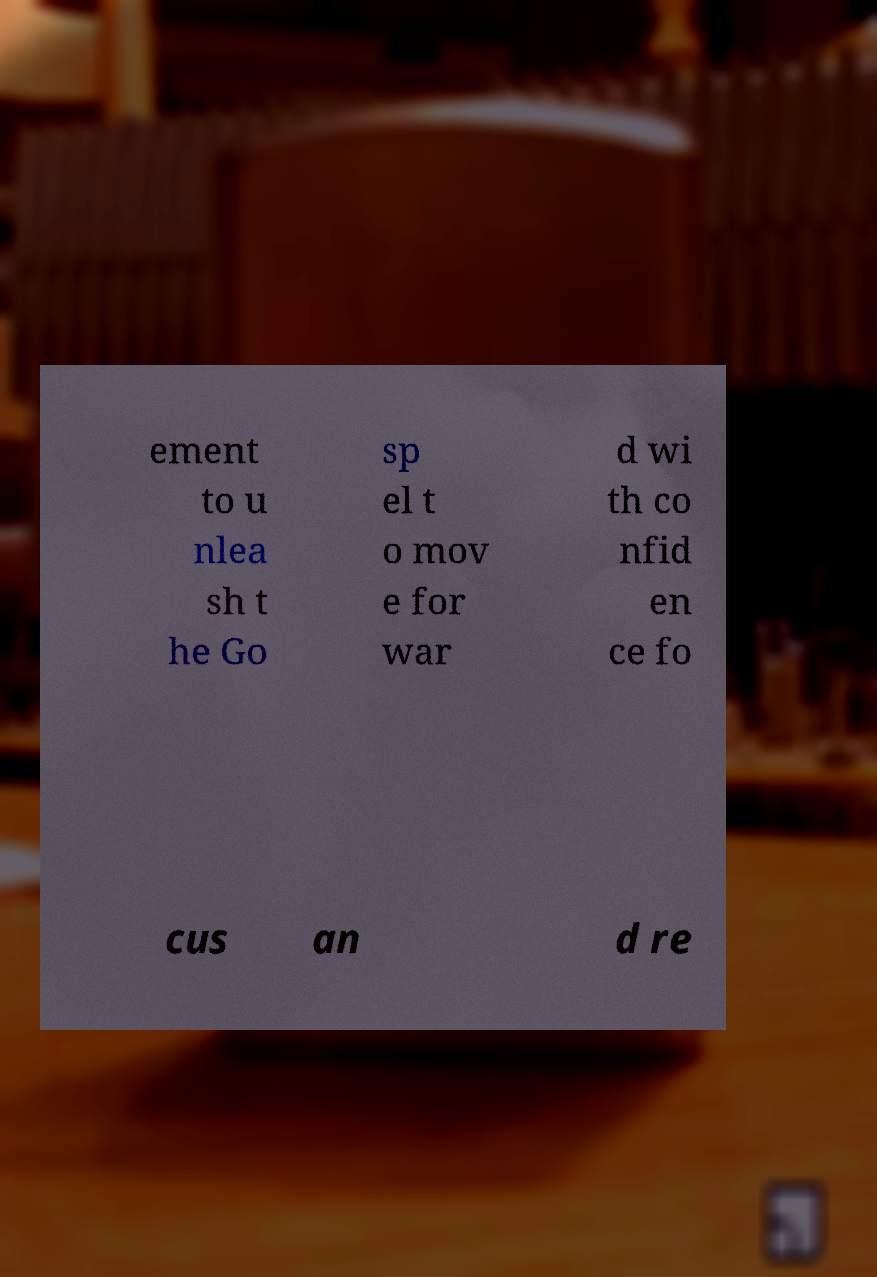I need the written content from this picture converted into text. Can you do that? ement to u nlea sh t he Go sp el t o mov e for war d wi th co nfid en ce fo cus an d re 